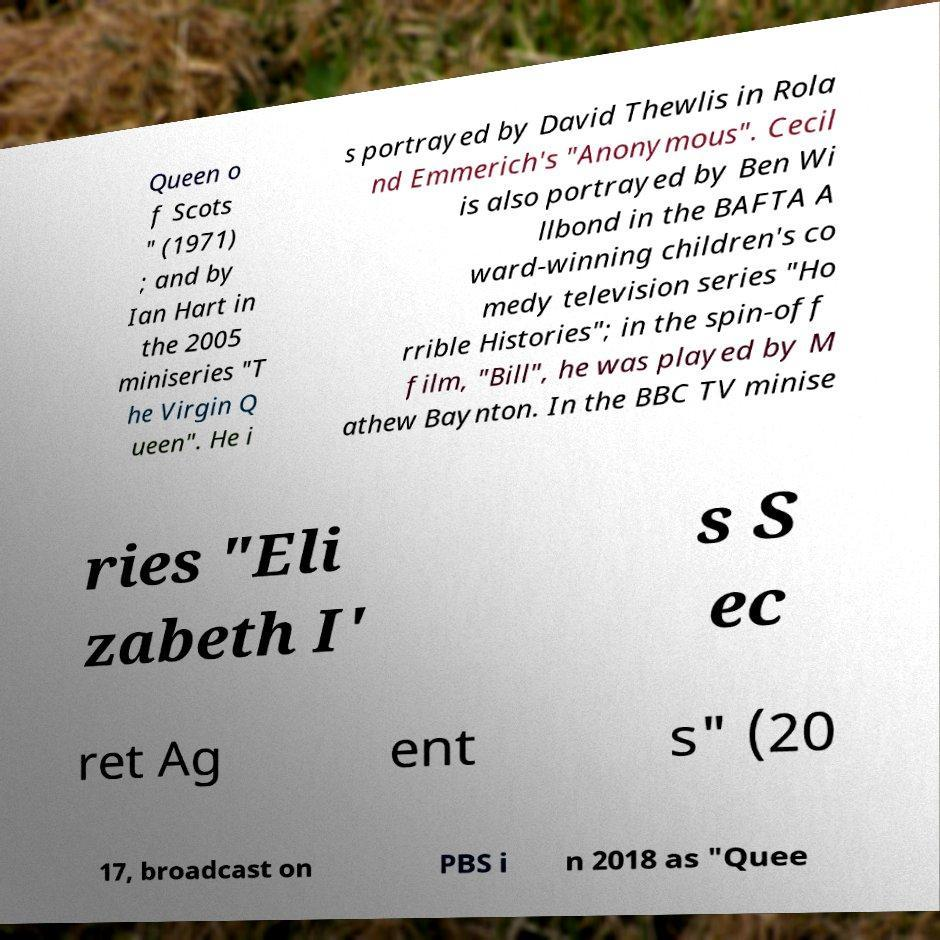Please read and relay the text visible in this image. What does it say? Queen o f Scots " (1971) ; and by Ian Hart in the 2005 miniseries "T he Virgin Q ueen". He i s portrayed by David Thewlis in Rola nd Emmerich's "Anonymous". Cecil is also portrayed by Ben Wi llbond in the BAFTA A ward-winning children's co medy television series "Ho rrible Histories"; in the spin-off film, "Bill", he was played by M athew Baynton. In the BBC TV minise ries "Eli zabeth I' s S ec ret Ag ent s" (20 17, broadcast on PBS i n 2018 as "Quee 